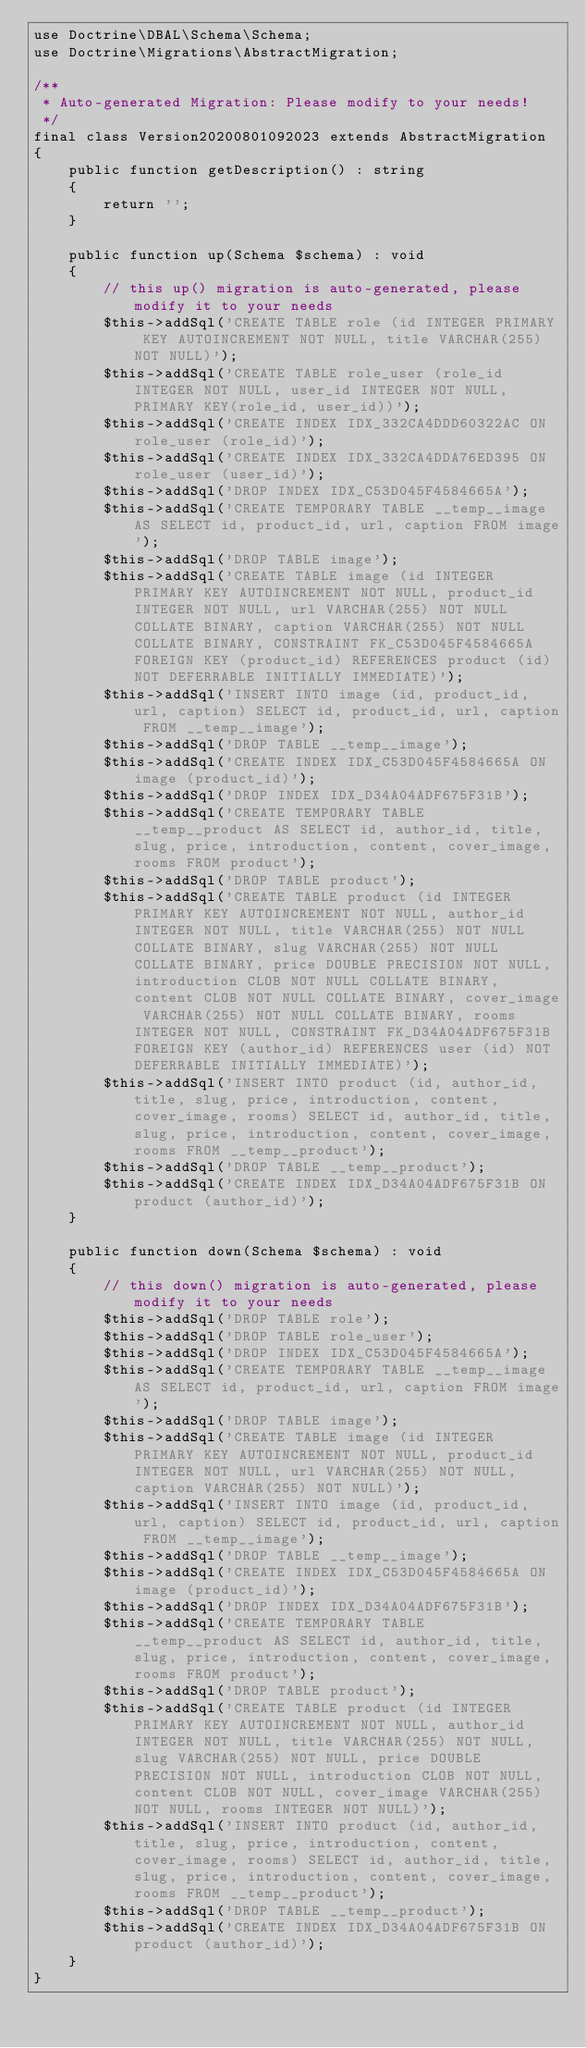Convert code to text. <code><loc_0><loc_0><loc_500><loc_500><_PHP_>use Doctrine\DBAL\Schema\Schema;
use Doctrine\Migrations\AbstractMigration;

/**
 * Auto-generated Migration: Please modify to your needs!
 */
final class Version20200801092023 extends AbstractMigration
{
    public function getDescription() : string
    {
        return '';
    }

    public function up(Schema $schema) : void
    {
        // this up() migration is auto-generated, please modify it to your needs
        $this->addSql('CREATE TABLE role (id INTEGER PRIMARY KEY AUTOINCREMENT NOT NULL, title VARCHAR(255) NOT NULL)');
        $this->addSql('CREATE TABLE role_user (role_id INTEGER NOT NULL, user_id INTEGER NOT NULL, PRIMARY KEY(role_id, user_id))');
        $this->addSql('CREATE INDEX IDX_332CA4DDD60322AC ON role_user (role_id)');
        $this->addSql('CREATE INDEX IDX_332CA4DDA76ED395 ON role_user (user_id)');
        $this->addSql('DROP INDEX IDX_C53D045F4584665A');
        $this->addSql('CREATE TEMPORARY TABLE __temp__image AS SELECT id, product_id, url, caption FROM image');
        $this->addSql('DROP TABLE image');
        $this->addSql('CREATE TABLE image (id INTEGER PRIMARY KEY AUTOINCREMENT NOT NULL, product_id INTEGER NOT NULL, url VARCHAR(255) NOT NULL COLLATE BINARY, caption VARCHAR(255) NOT NULL COLLATE BINARY, CONSTRAINT FK_C53D045F4584665A FOREIGN KEY (product_id) REFERENCES product (id) NOT DEFERRABLE INITIALLY IMMEDIATE)');
        $this->addSql('INSERT INTO image (id, product_id, url, caption) SELECT id, product_id, url, caption FROM __temp__image');
        $this->addSql('DROP TABLE __temp__image');
        $this->addSql('CREATE INDEX IDX_C53D045F4584665A ON image (product_id)');
        $this->addSql('DROP INDEX IDX_D34A04ADF675F31B');
        $this->addSql('CREATE TEMPORARY TABLE __temp__product AS SELECT id, author_id, title, slug, price, introduction, content, cover_image, rooms FROM product');
        $this->addSql('DROP TABLE product');
        $this->addSql('CREATE TABLE product (id INTEGER PRIMARY KEY AUTOINCREMENT NOT NULL, author_id INTEGER NOT NULL, title VARCHAR(255) NOT NULL COLLATE BINARY, slug VARCHAR(255) NOT NULL COLLATE BINARY, price DOUBLE PRECISION NOT NULL, introduction CLOB NOT NULL COLLATE BINARY, content CLOB NOT NULL COLLATE BINARY, cover_image VARCHAR(255) NOT NULL COLLATE BINARY, rooms INTEGER NOT NULL, CONSTRAINT FK_D34A04ADF675F31B FOREIGN KEY (author_id) REFERENCES user (id) NOT DEFERRABLE INITIALLY IMMEDIATE)');
        $this->addSql('INSERT INTO product (id, author_id, title, slug, price, introduction, content, cover_image, rooms) SELECT id, author_id, title, slug, price, introduction, content, cover_image, rooms FROM __temp__product');
        $this->addSql('DROP TABLE __temp__product');
        $this->addSql('CREATE INDEX IDX_D34A04ADF675F31B ON product (author_id)');
    }

    public function down(Schema $schema) : void
    {
        // this down() migration is auto-generated, please modify it to your needs
        $this->addSql('DROP TABLE role');
        $this->addSql('DROP TABLE role_user');
        $this->addSql('DROP INDEX IDX_C53D045F4584665A');
        $this->addSql('CREATE TEMPORARY TABLE __temp__image AS SELECT id, product_id, url, caption FROM image');
        $this->addSql('DROP TABLE image');
        $this->addSql('CREATE TABLE image (id INTEGER PRIMARY KEY AUTOINCREMENT NOT NULL, product_id INTEGER NOT NULL, url VARCHAR(255) NOT NULL, caption VARCHAR(255) NOT NULL)');
        $this->addSql('INSERT INTO image (id, product_id, url, caption) SELECT id, product_id, url, caption FROM __temp__image');
        $this->addSql('DROP TABLE __temp__image');
        $this->addSql('CREATE INDEX IDX_C53D045F4584665A ON image (product_id)');
        $this->addSql('DROP INDEX IDX_D34A04ADF675F31B');
        $this->addSql('CREATE TEMPORARY TABLE __temp__product AS SELECT id, author_id, title, slug, price, introduction, content, cover_image, rooms FROM product');
        $this->addSql('DROP TABLE product');
        $this->addSql('CREATE TABLE product (id INTEGER PRIMARY KEY AUTOINCREMENT NOT NULL, author_id INTEGER NOT NULL, title VARCHAR(255) NOT NULL, slug VARCHAR(255) NOT NULL, price DOUBLE PRECISION NOT NULL, introduction CLOB NOT NULL, content CLOB NOT NULL, cover_image VARCHAR(255) NOT NULL, rooms INTEGER NOT NULL)');
        $this->addSql('INSERT INTO product (id, author_id, title, slug, price, introduction, content, cover_image, rooms) SELECT id, author_id, title, slug, price, introduction, content, cover_image, rooms FROM __temp__product');
        $this->addSql('DROP TABLE __temp__product');
        $this->addSql('CREATE INDEX IDX_D34A04ADF675F31B ON product (author_id)');
    }
}
</code> 